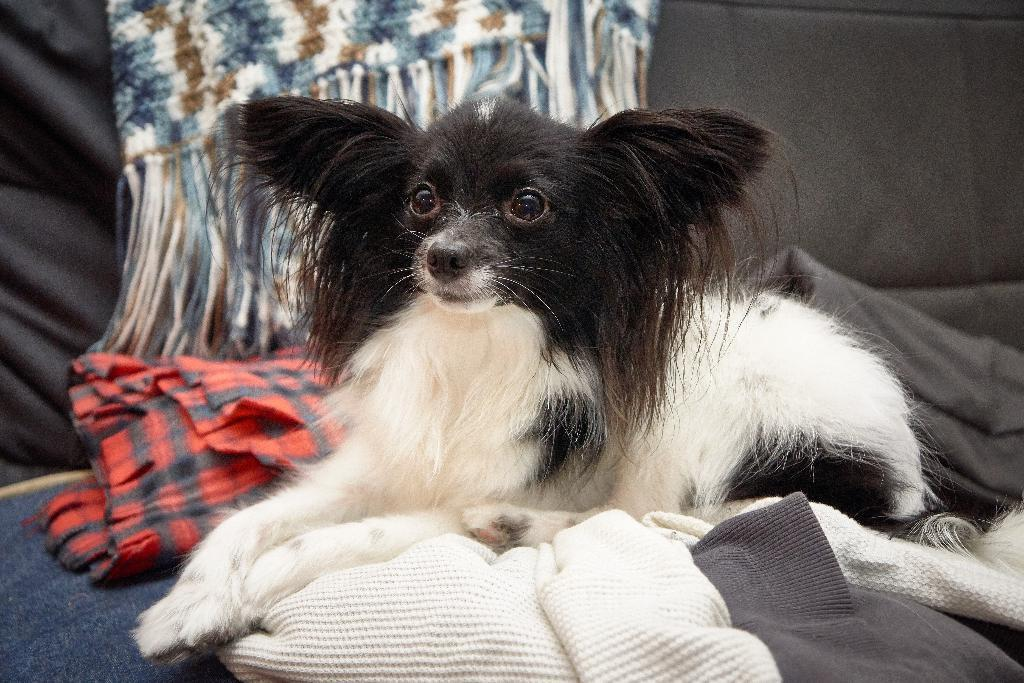What animal can be seen in the image? There is a dog in the image. Where is the dog located in the image? The dog is sitting on the bed. What else is on the bed in the image? There are clothes placed on the bed. What type of kitten is sitting next to the dog on the bed? There is no kitten present in the image; only a dog is visible. What facial expression does the dog have in the image? The image does not show the dog's face, so it is not possible to determine its facial expression. 